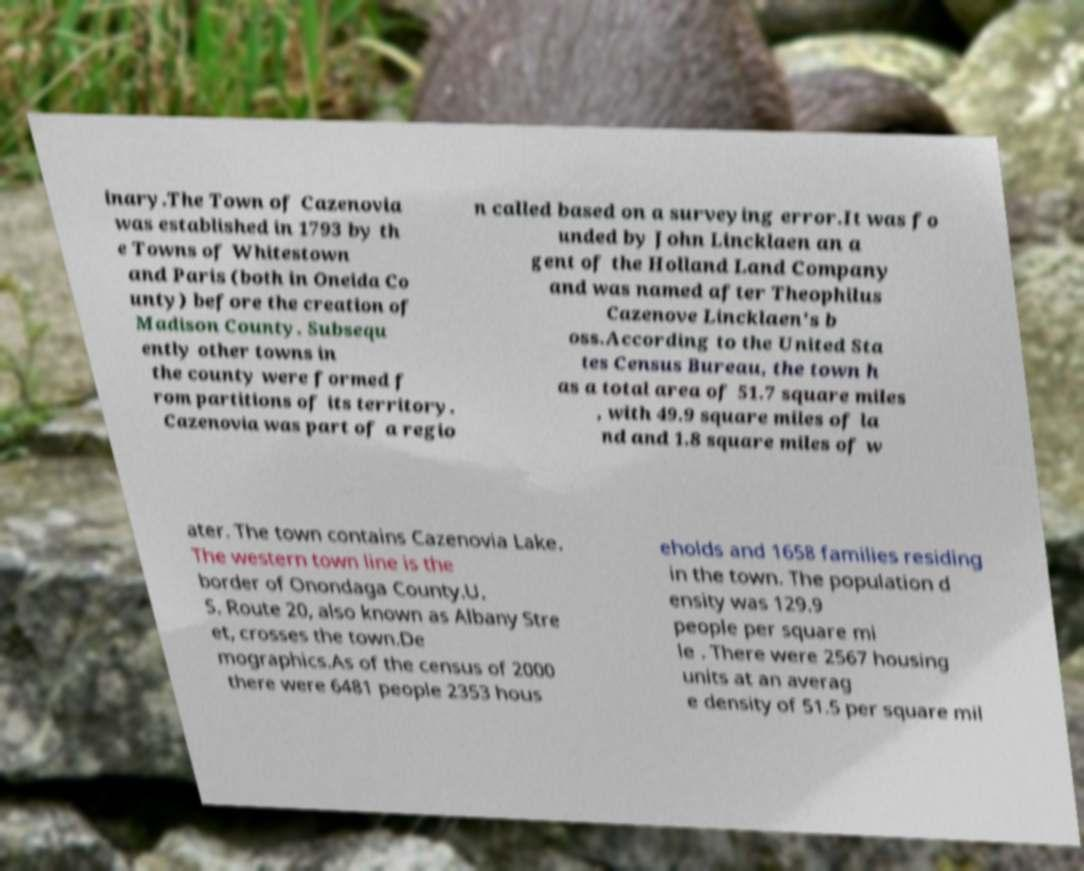For documentation purposes, I need the text within this image transcribed. Could you provide that? inary.The Town of Cazenovia was established in 1793 by th e Towns of Whitestown and Paris (both in Oneida Co unty) before the creation of Madison County. Subsequ ently other towns in the county were formed f rom partitions of its territory. Cazenovia was part of a regio n called based on a surveying error.It was fo unded by John Lincklaen an a gent of the Holland Land Company and was named after Theophilus Cazenove Lincklaen's b oss.According to the United Sta tes Census Bureau, the town h as a total area of 51.7 square miles , with 49.9 square miles of la nd and 1.8 square miles of w ater. The town contains Cazenovia Lake. The western town line is the border of Onondaga County.U. S. Route 20, also known as Albany Stre et, crosses the town.De mographics.As of the census of 2000 there were 6481 people 2353 hous eholds and 1658 families residing in the town. The population d ensity was 129.9 people per square mi le . There were 2567 housing units at an averag e density of 51.5 per square mil 